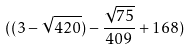Convert formula to latex. <formula><loc_0><loc_0><loc_500><loc_500>( ( 3 - \sqrt { 4 2 0 } ) - \frac { \sqrt { 7 5 } } { 4 0 9 } + 1 6 8 )</formula> 